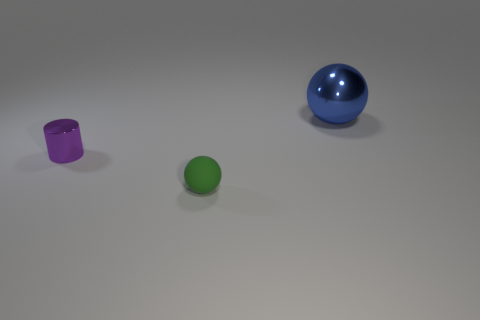There is a object in front of the metallic object that is to the left of the sphere in front of the large metal thing; what is its color?
Your answer should be very brief. Green. How many other things are the same shape as the small green thing?
Keep it short and to the point. 1. What is the shape of the object on the right side of the green object?
Keep it short and to the point. Sphere. Is there a small sphere that is in front of the metallic thing on the right side of the green ball?
Ensure brevity in your answer.  Yes. There is a object that is both behind the green ball and in front of the blue metallic thing; what is its color?
Your answer should be very brief. Purple. There is a metallic object that is to the left of the ball in front of the shiny ball; are there any rubber objects that are on the right side of it?
Ensure brevity in your answer.  Yes. The green rubber object that is the same shape as the blue thing is what size?
Your response must be concise. Small. Is there anything else that has the same material as the green object?
Offer a very short reply. No. Are there any large blue objects?
Make the answer very short. Yes. There is a metal object to the left of the object that is in front of the metallic thing in front of the big object; how big is it?
Your answer should be compact. Small. 